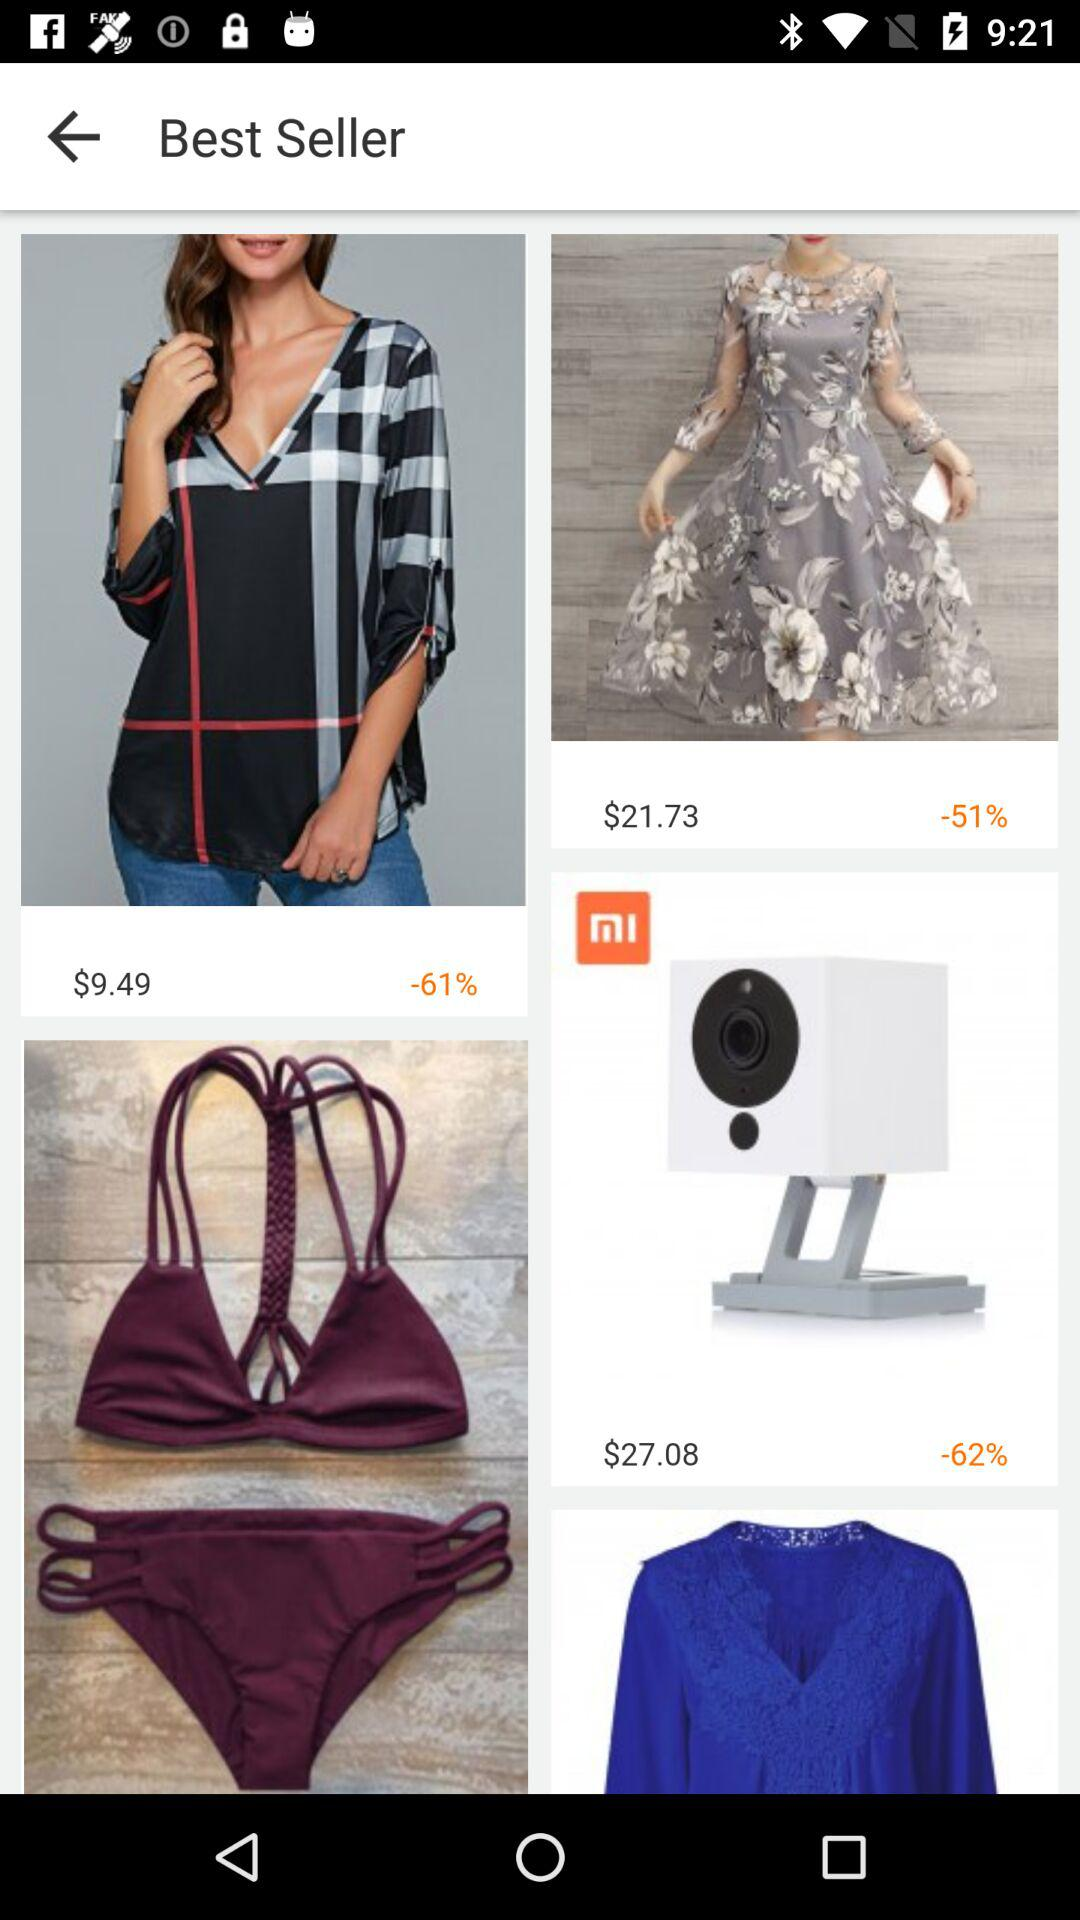What is the price of a woman's top? The price of a woman's top is $9.49. 